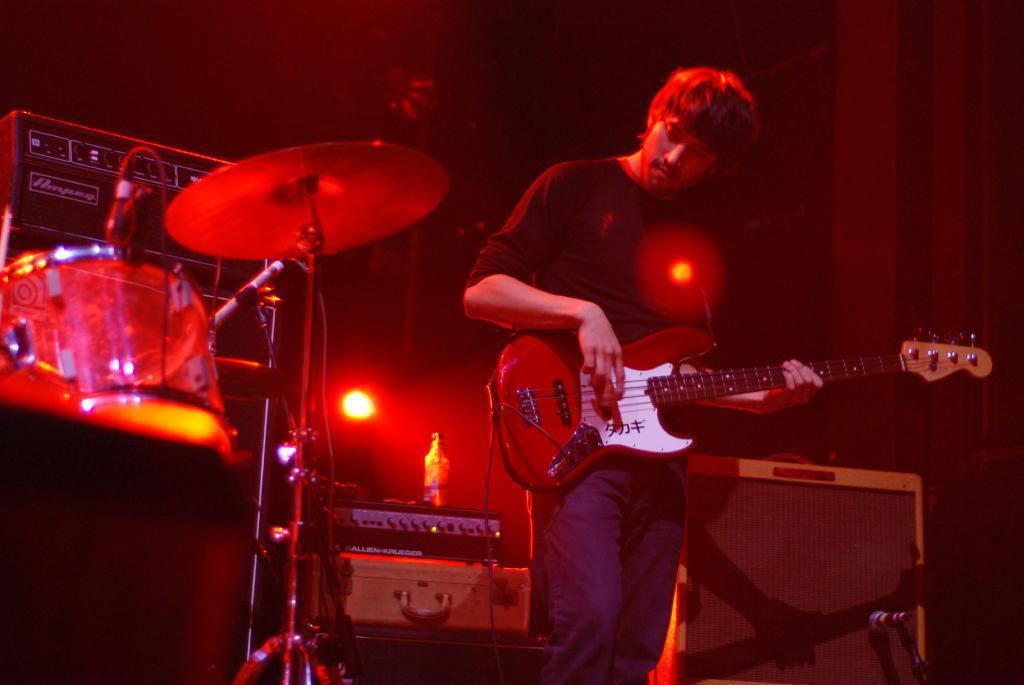In one or two sentences, can you explain what this image depicts? In the image in the center we can see one person playing guitar, and back of him they were few musical instruments. And on the right corner there is a microphone. 